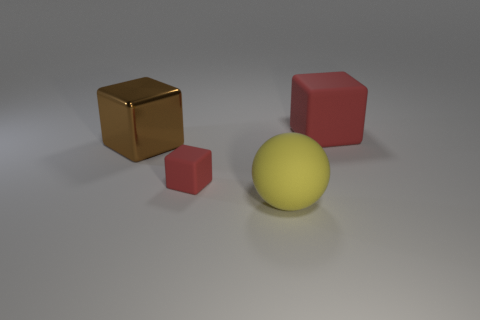How many yellow balls are there?
Ensure brevity in your answer.  1. There is a large yellow ball; are there any big yellow balls behind it?
Offer a very short reply. No. Are the cube right of the yellow thing and the red block that is to the left of the large yellow matte sphere made of the same material?
Your answer should be compact. Yes. Is the number of big objects in front of the tiny red object less than the number of red matte cubes?
Your answer should be compact. Yes. The large thing that is in front of the small object is what color?
Offer a terse response. Yellow. The small red object that is to the left of the big matte thing that is in front of the brown thing is made of what material?
Provide a succinct answer. Rubber. Are there any green rubber cylinders that have the same size as the brown metal thing?
Ensure brevity in your answer.  No. What number of things are blocks behind the small matte block or red things that are behind the large yellow sphere?
Offer a terse response. 3. There is a red cube behind the small thing; is it the same size as the cube on the left side of the small red rubber object?
Offer a terse response. Yes. There is a object that is right of the large sphere; is there a red thing that is behind it?
Make the answer very short. No. 